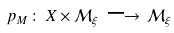Convert formula to latex. <formula><loc_0><loc_0><loc_500><loc_500>p _ { M } \, \colon \, X \times { \mathcal { M } } _ { \xi } \, \longrightarrow \, { \mathcal { M } } _ { \xi }</formula> 